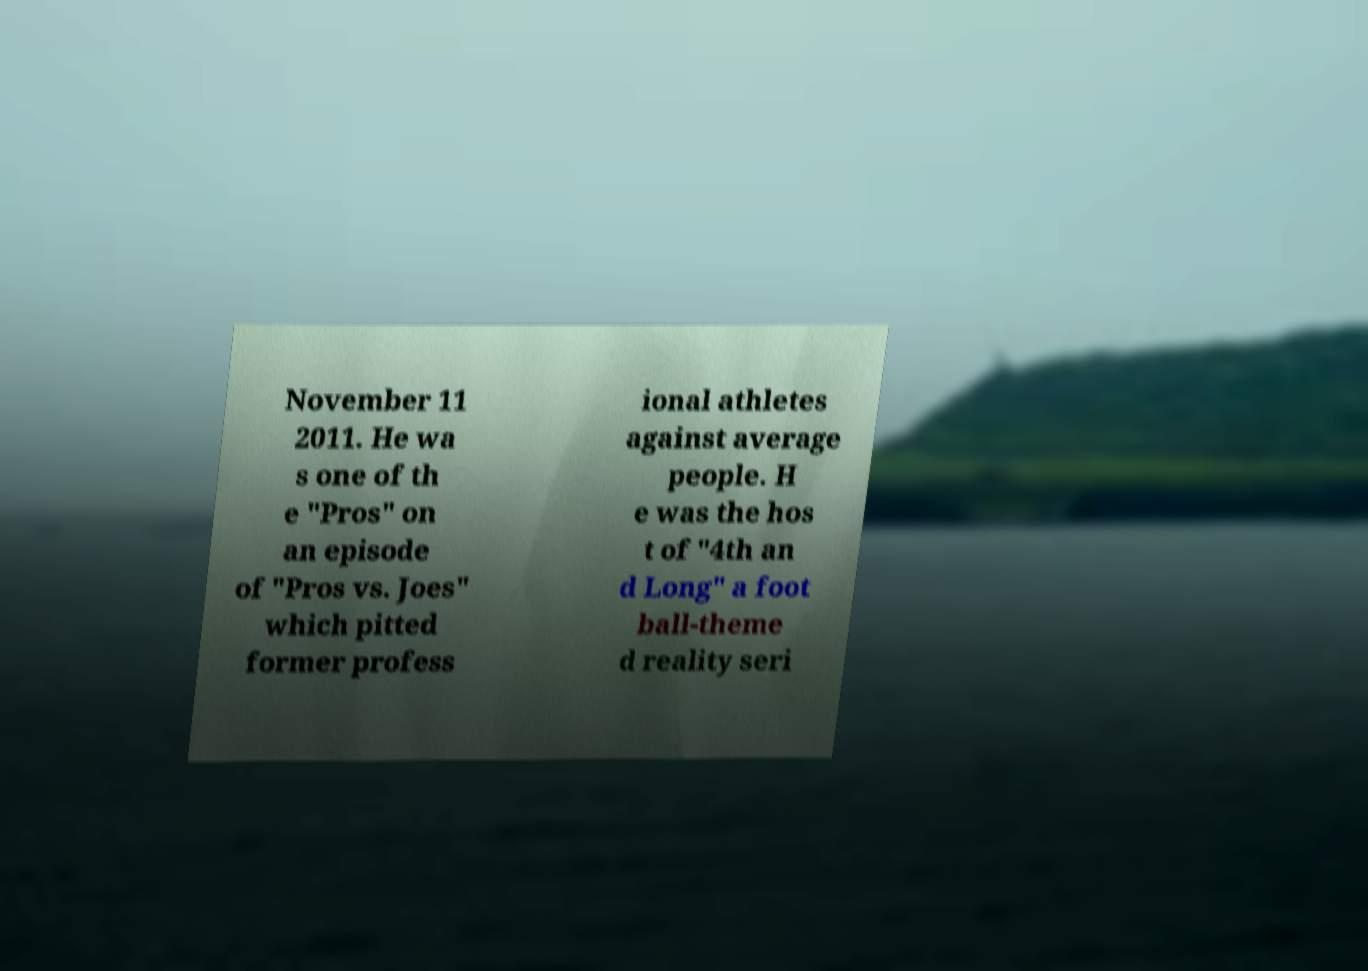Could you extract and type out the text from this image? November 11 2011. He wa s one of th e "Pros" on an episode of "Pros vs. Joes" which pitted former profess ional athletes against average people. H e was the hos t of "4th an d Long" a foot ball-theme d reality seri 